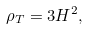<formula> <loc_0><loc_0><loc_500><loc_500>\rho _ { T } = 3 H ^ { 2 } ,</formula> 